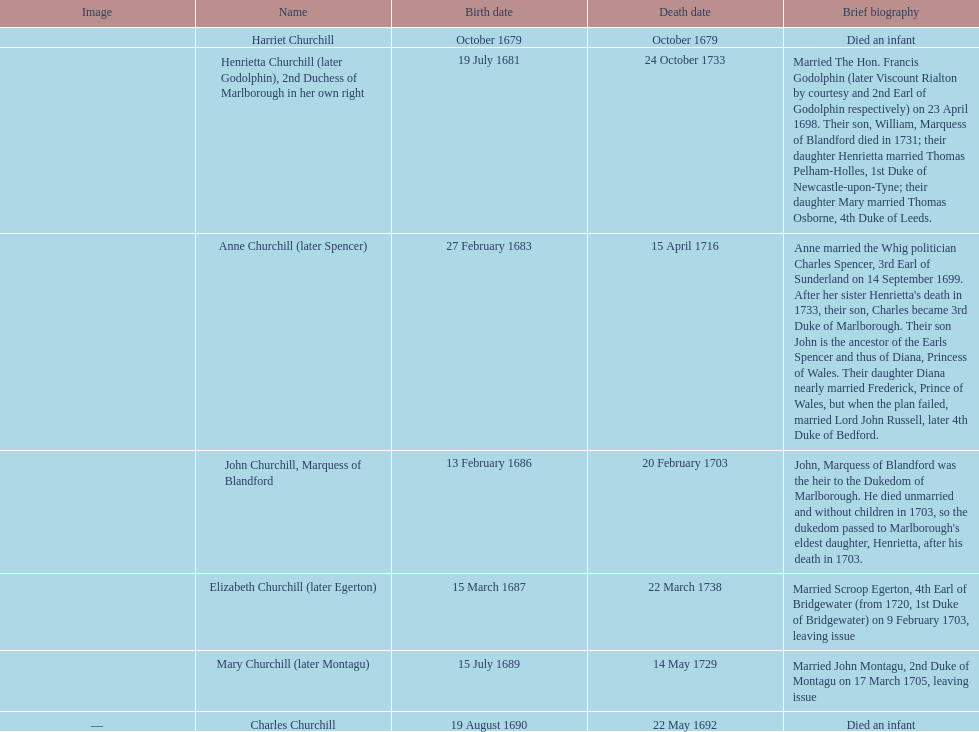How many offspring were born in february? 2. 